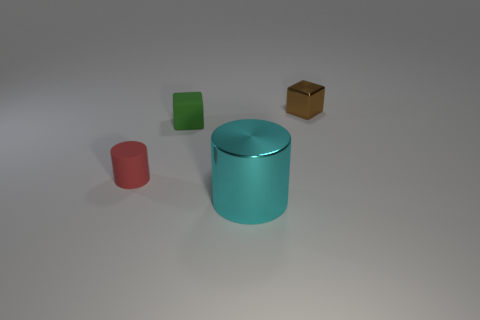Add 1 brown metal balls. How many objects exist? 5 Add 4 tiny red cylinders. How many tiny red cylinders are left? 5 Add 4 big green matte objects. How many big green matte objects exist? 4 Subtract 0 green spheres. How many objects are left? 4 Subtract all tiny purple metallic cubes. Subtract all tiny cubes. How many objects are left? 2 